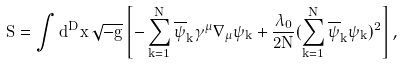<formula> <loc_0><loc_0><loc_500><loc_500>S = \int d ^ { D } x \, \sqrt { - g } \left [ - \sum ^ { N } _ { k = 1 } \overline { \psi } _ { k } \gamma ^ { \mu } \nabla _ { \mu } \psi _ { k } + \frac { \lambda _ { 0 } } { 2 N } ( \sum ^ { N } _ { k = 1 } \overline { \psi } _ { k } \psi _ { k } ) ^ { 2 } \right ] ,</formula> 